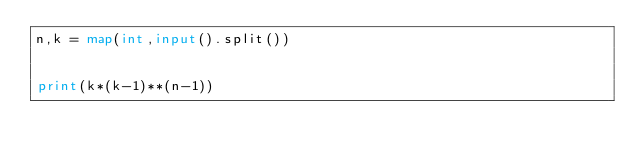<code> <loc_0><loc_0><loc_500><loc_500><_Python_>n,k = map(int,input().split())


print(k*(k-1)**(n-1))</code> 